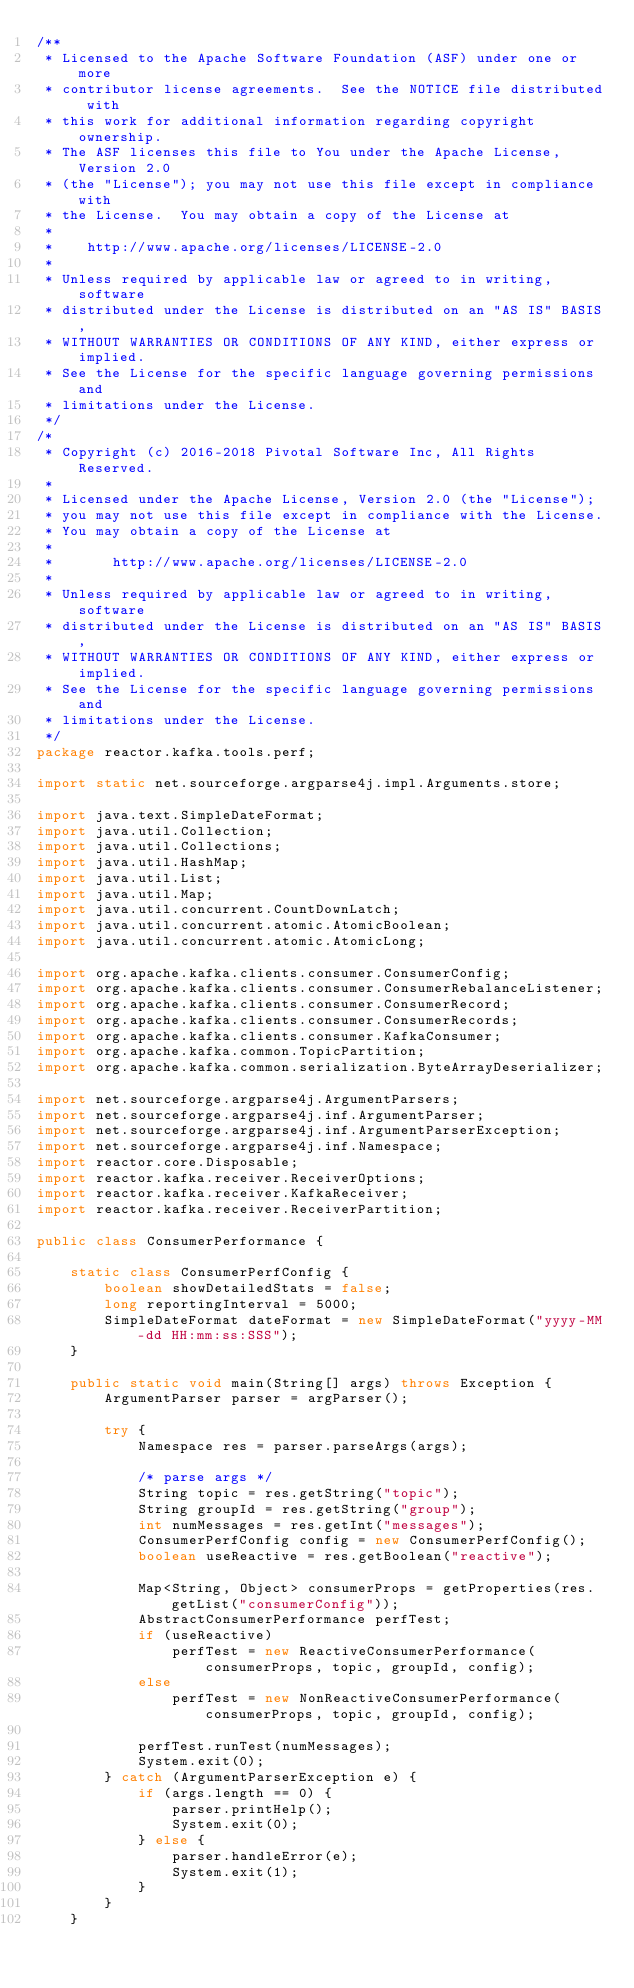<code> <loc_0><loc_0><loc_500><loc_500><_Java_>/**
 * Licensed to the Apache Software Foundation (ASF) under one or more
 * contributor license agreements.  See the NOTICE file distributed with
 * this work for additional information regarding copyright ownership.
 * The ASF licenses this file to You under the Apache License, Version 2.0
 * (the "License"); you may not use this file except in compliance with
 * the License.  You may obtain a copy of the License at
 *
 *    http://www.apache.org/licenses/LICENSE-2.0
 *
 * Unless required by applicable law or agreed to in writing, software
 * distributed under the License is distributed on an "AS IS" BASIS,
 * WITHOUT WARRANTIES OR CONDITIONS OF ANY KIND, either express or implied.
 * See the License for the specific language governing permissions and
 * limitations under the License.
 */
/*
 * Copyright (c) 2016-2018 Pivotal Software Inc, All Rights Reserved.
 *
 * Licensed under the Apache License, Version 2.0 (the "License");
 * you may not use this file except in compliance with the License.
 * You may obtain a copy of the License at
 *
 *       http://www.apache.org/licenses/LICENSE-2.0
 *
 * Unless required by applicable law or agreed to in writing, software
 * distributed under the License is distributed on an "AS IS" BASIS,
 * WITHOUT WARRANTIES OR CONDITIONS OF ANY KIND, either express or implied.
 * See the License for the specific language governing permissions and
 * limitations under the License.
 */
package reactor.kafka.tools.perf;

import static net.sourceforge.argparse4j.impl.Arguments.store;

import java.text.SimpleDateFormat;
import java.util.Collection;
import java.util.Collections;
import java.util.HashMap;
import java.util.List;
import java.util.Map;
import java.util.concurrent.CountDownLatch;
import java.util.concurrent.atomic.AtomicBoolean;
import java.util.concurrent.atomic.AtomicLong;

import org.apache.kafka.clients.consumer.ConsumerConfig;
import org.apache.kafka.clients.consumer.ConsumerRebalanceListener;
import org.apache.kafka.clients.consumer.ConsumerRecord;
import org.apache.kafka.clients.consumer.ConsumerRecords;
import org.apache.kafka.clients.consumer.KafkaConsumer;
import org.apache.kafka.common.TopicPartition;
import org.apache.kafka.common.serialization.ByteArrayDeserializer;

import net.sourceforge.argparse4j.ArgumentParsers;
import net.sourceforge.argparse4j.inf.ArgumentParser;
import net.sourceforge.argparse4j.inf.ArgumentParserException;
import net.sourceforge.argparse4j.inf.Namespace;
import reactor.core.Disposable;
import reactor.kafka.receiver.ReceiverOptions;
import reactor.kafka.receiver.KafkaReceiver;
import reactor.kafka.receiver.ReceiverPartition;

public class ConsumerPerformance {

    static class ConsumerPerfConfig {
        boolean showDetailedStats = false;
        long reportingInterval = 5000;
        SimpleDateFormat dateFormat = new SimpleDateFormat("yyyy-MM-dd HH:mm:ss:SSS");
    }

    public static void main(String[] args) throws Exception {
        ArgumentParser parser = argParser();

        try {
            Namespace res = parser.parseArgs(args);

            /* parse args */
            String topic = res.getString("topic");
            String groupId = res.getString("group");
            int numMessages = res.getInt("messages");
            ConsumerPerfConfig config = new ConsumerPerfConfig();
            boolean useReactive = res.getBoolean("reactive");

            Map<String, Object> consumerProps = getProperties(res.getList("consumerConfig"));
            AbstractConsumerPerformance perfTest;
            if (useReactive)
                perfTest = new ReactiveConsumerPerformance(consumerProps, topic, groupId, config);
            else
                perfTest = new NonReactiveConsumerPerformance(consumerProps, topic, groupId, config);

            perfTest.runTest(numMessages);
            System.exit(0);
        } catch (ArgumentParserException e) {
            if (args.length == 0) {
                parser.printHelp();
                System.exit(0);
            } else {
                parser.handleError(e);
                System.exit(1);
            }
        }
    }
</code> 